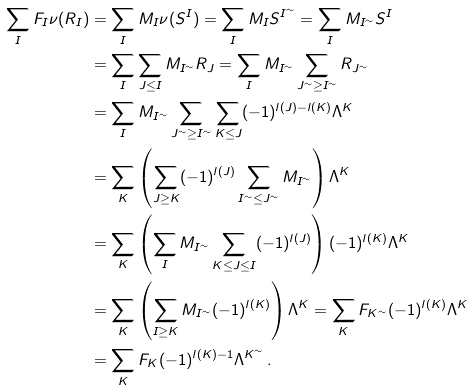Convert formula to latex. <formula><loc_0><loc_0><loc_500><loc_500>\sum _ { I } F _ { I } \nu ( R _ { I } ) & = \sum _ { I } M _ { I } \nu ( S ^ { I } ) = \sum _ { I } M _ { I } S ^ { I ^ { \sim } } = \sum _ { I } M _ { I ^ { \sim } } S ^ { I } \\ & = \sum _ { I } \sum _ { J \leq I } M _ { I ^ { \sim } } R _ { J } = \sum _ { I } M _ { I ^ { \sim } } \sum _ { J ^ { \sim } \geq I ^ { \sim } } R _ { J ^ { \sim } } \\ & = \sum _ { I } M _ { I ^ { \sim } } \sum _ { J ^ { \sim } \geq I ^ { \sim } } \sum _ { K \leq J } ( - 1 ) ^ { l ( J ) - l ( K ) } \Lambda ^ { K } \\ & = \sum _ { K } \left ( \sum _ { J \geq K } ( - 1 ) ^ { l ( J ) } \sum _ { I ^ { \sim } \leq J ^ { \sim } } M _ { I ^ { \sim } } \right ) \Lambda ^ { K } \\ & = \sum _ { K } \left ( \sum _ { I } M _ { I ^ { \sim } } \sum _ { K \leq J \leq I } ( - 1 ) ^ { l ( J ) } \right ) ( - 1 ) ^ { l ( K ) } \Lambda ^ { K } \\ & = \sum _ { K } \left ( \sum _ { I \geq K } M _ { I ^ { \sim } } ( - 1 ) ^ { l ( K ) } \right ) \Lambda ^ { K } = \sum _ { K } F _ { K ^ { \sim } } ( - 1 ) ^ { l ( K ) } \Lambda ^ { K } \\ & = \sum _ { K } F _ { K } ( - 1 ) ^ { l ( K ) - 1 } \Lambda ^ { K ^ { \sim } } \, .</formula> 